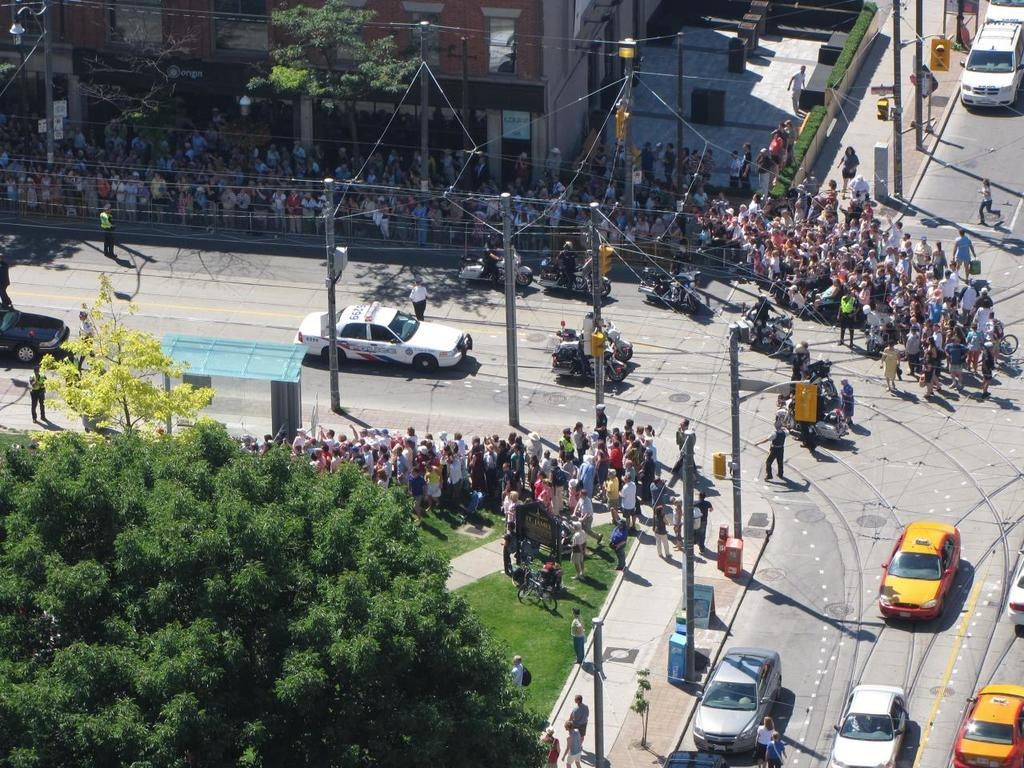What is happening on the road in the image? There are persons moving on the road, and vehicles are also moving. What type of natural elements can be seen in the image? Trees and plants are present in the image. What type of structures are visible in the image? Buildings are visible in the image. What type of poles are present in the image? Traffic signal poles are present in the image. What type of suit is the deer wearing in the image? There is no deer present in the image, and therefore no suit can be observed. 